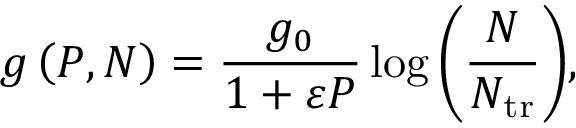Convert formula to latex. <formula><loc_0><loc_0><loc_500><loc_500>g \left ( P , N \right ) = \frac { g _ { 0 } } { 1 + \varepsilon P } \log { \left ( \frac { N } { N _ { t r } } \right ) } ,</formula> 